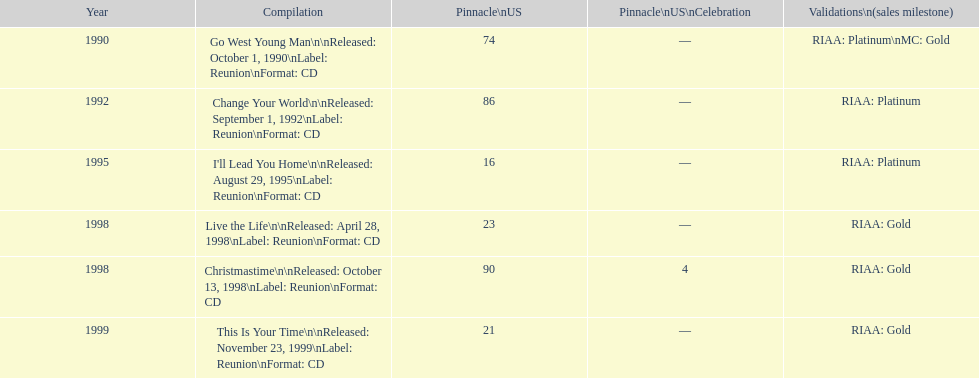Which michael w smith album had the highest ranking on the us chart? I'll Lead You Home. 